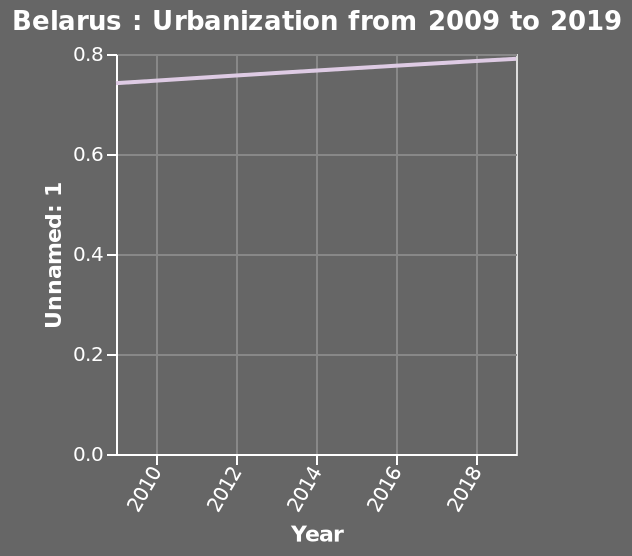<image>
Has urbanisation in Belarus been steady or fluctuating over the last 20 years? Urbanisation in Belarus has been steadily increasing over the last 20 years. What is the minimum value displayed on the x-axis? The minimum value displayed on the x-axis is 2010. please enumerates aspects of the construction of the chart Belarus : Urbanization from 2009 to 2019 is a line diagram. A linear scale with a minimum of 2010 and a maximum of 2018 can be found along the x-axis, labeled Year. Unnamed: 1 is plotted along the y-axis. Offer a thorough analysis of the image. Urbanisation has increased in Belarus over the last 20 years. It has increased by about 0.5 in this time period. 